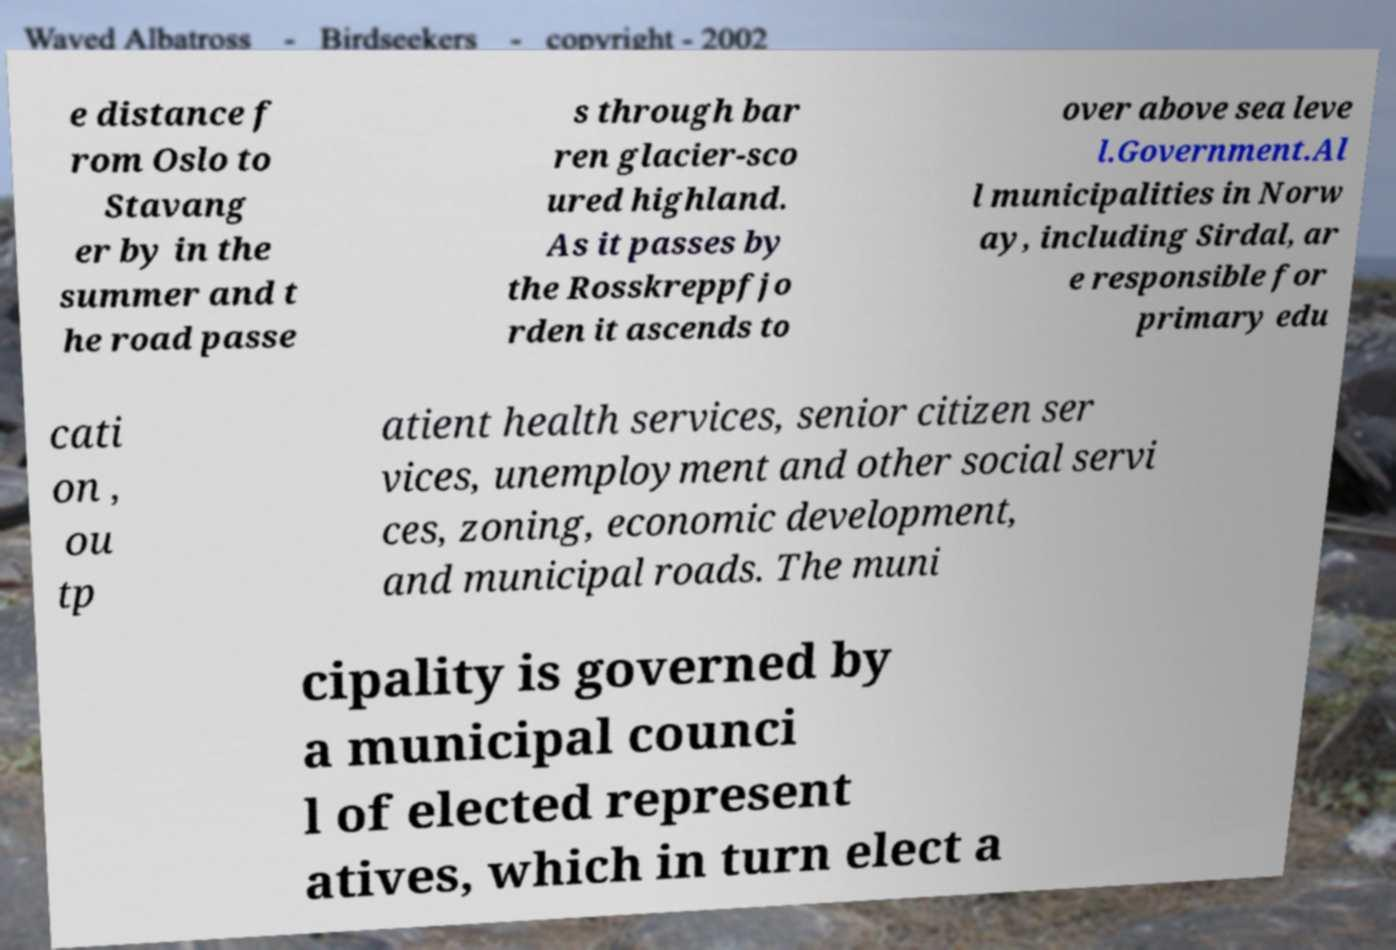Can you accurately transcribe the text from the provided image for me? e distance f rom Oslo to Stavang er by in the summer and t he road passe s through bar ren glacier-sco ured highland. As it passes by the Rosskreppfjo rden it ascends to over above sea leve l.Government.Al l municipalities in Norw ay, including Sirdal, ar e responsible for primary edu cati on , ou tp atient health services, senior citizen ser vices, unemployment and other social servi ces, zoning, economic development, and municipal roads. The muni cipality is governed by a municipal counci l of elected represent atives, which in turn elect a 